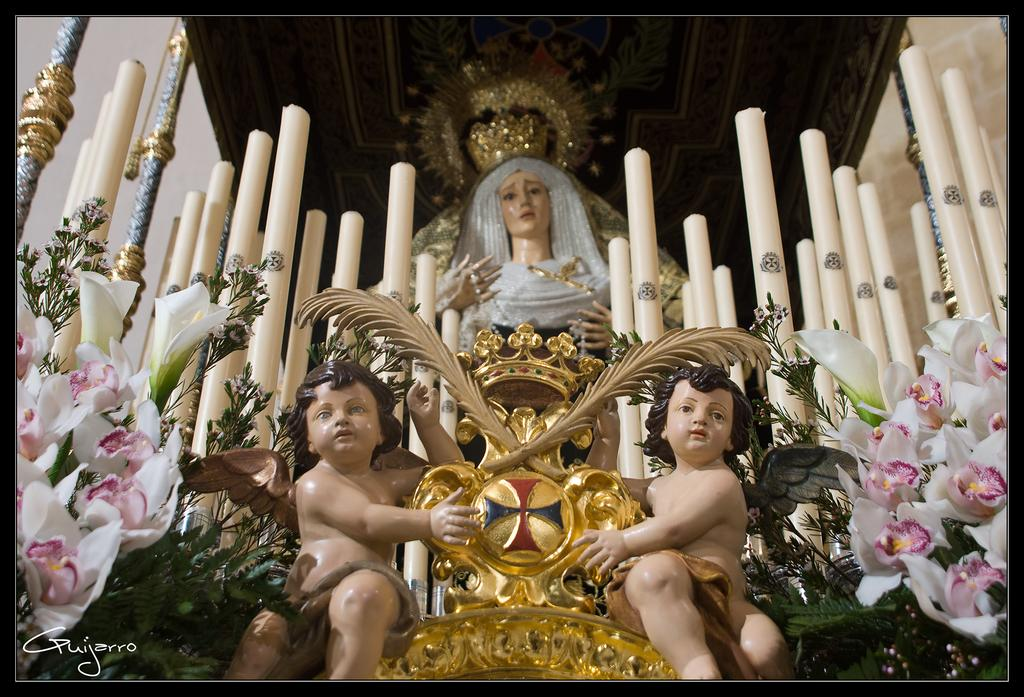What type of objects can be seen in the image? There are statues, candles, flowers, and leaves in the image. Can you describe the lighting in the image? There are candles and a chandelier on the rooftop in the image, which provide lighting. What is written at the bottom of the image? There is some text at the bottom of the image. What type of wound can be seen on the statue's neck in the image? There are no wounds or statues with necks present in the image. 